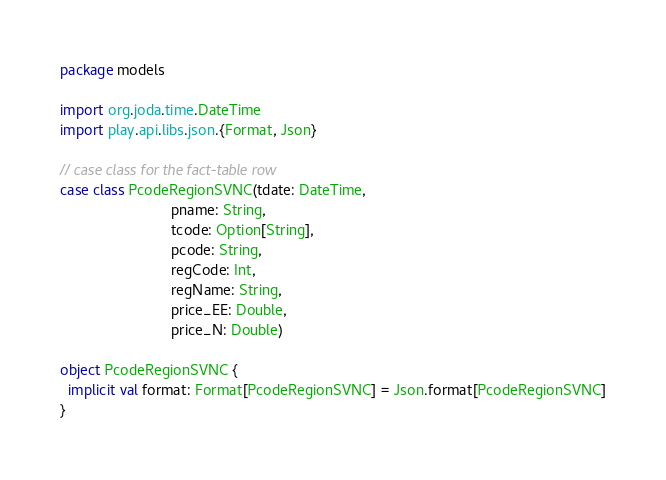Convert code to text. <code><loc_0><loc_0><loc_500><loc_500><_Scala_>package models

import org.joda.time.DateTime
import play.api.libs.json.{Format, Json}

// case class for the fact-table row
case class PcodeRegionSVNC(tdate: DateTime,
                           pname: String,
                           tcode: Option[String],
                           pcode: String,
                           regCode: Int,
                           regName: String,
                           price_EE: Double,
                           price_N: Double)

object PcodeRegionSVNC {
  implicit val format: Format[PcodeRegionSVNC] = Json.format[PcodeRegionSVNC]
}

</code> 